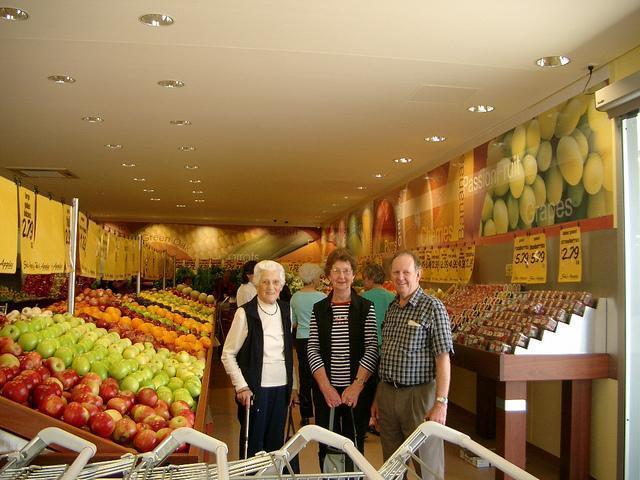How many people are in the photo?
Give a very brief answer. 4. How many apples are there?
Give a very brief answer. 2. How many bottles are there?
Give a very brief answer. 0. 